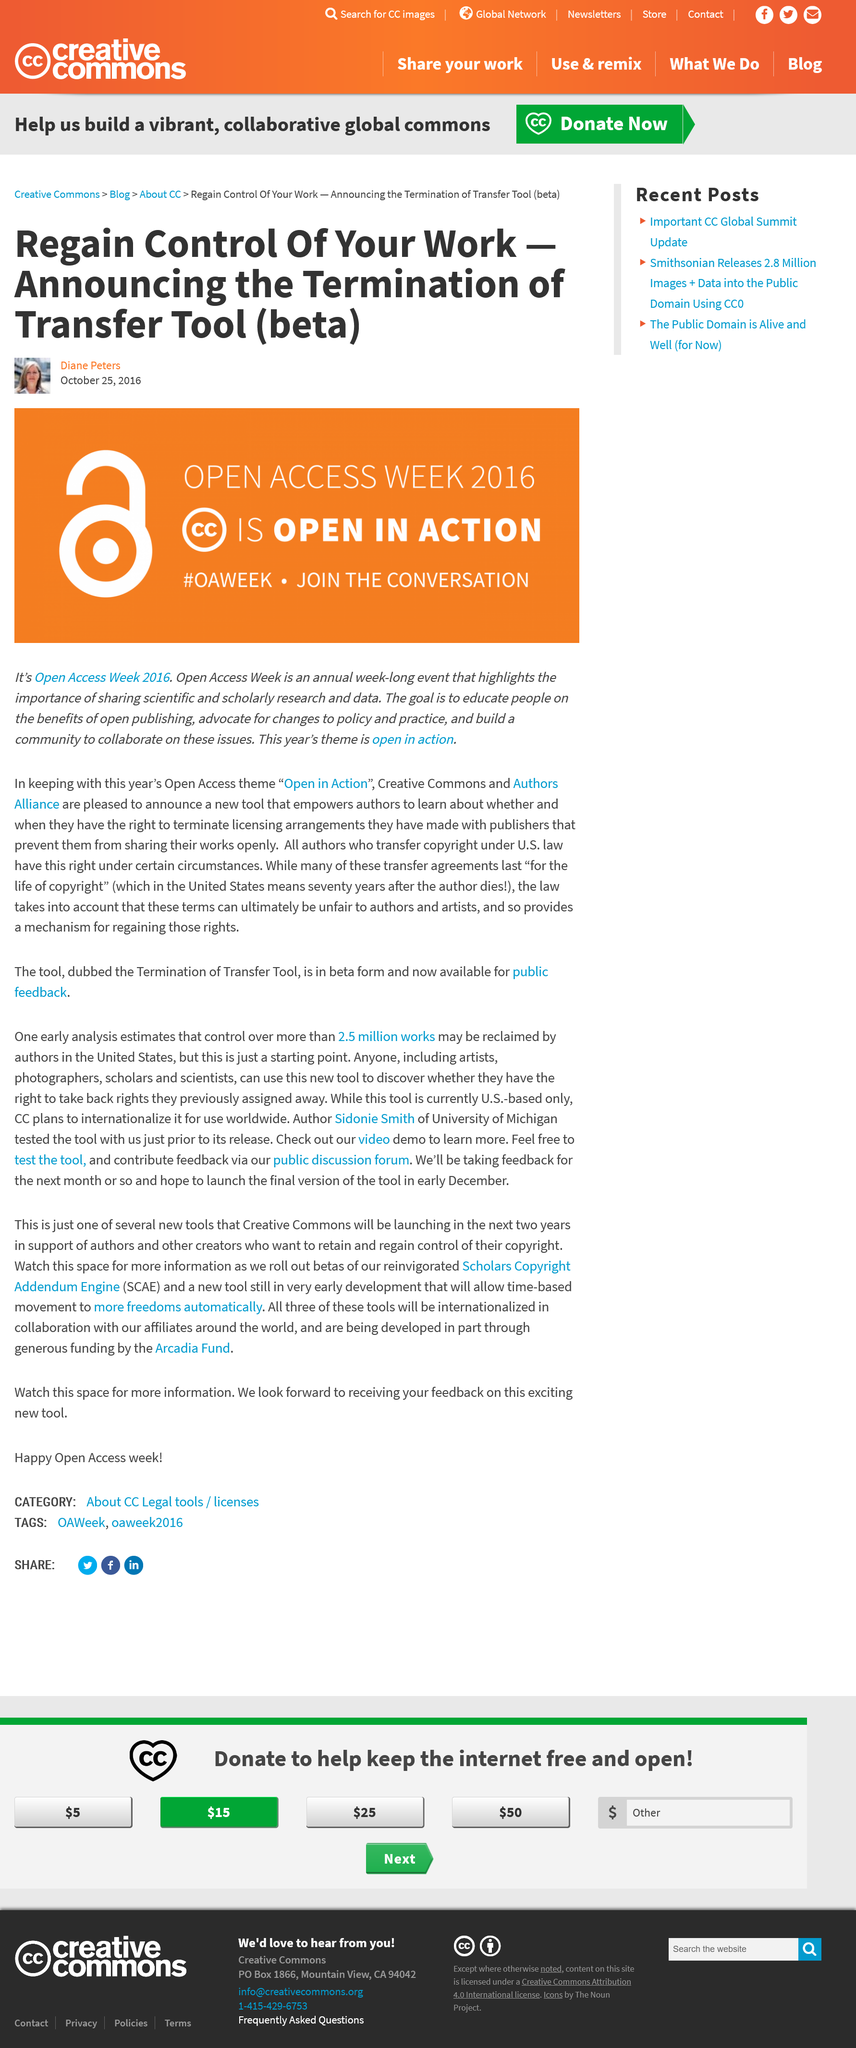Specify some key components in this picture. Diane Peters is reporting on Open Access Week 2016. The Authors Alliance announced the 'Termination of Transfer Tool (beta)' at the event. Open Access Week 2016's theme is "open in action. 